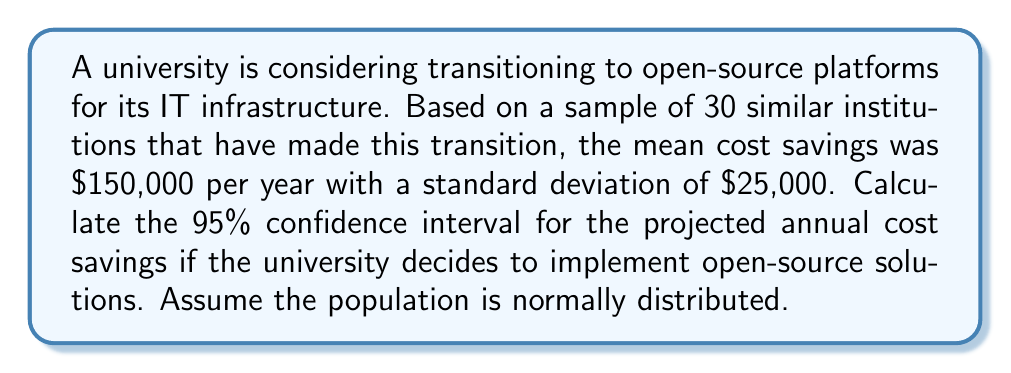Teach me how to tackle this problem. To calculate the 95% confidence interval, we'll follow these steps:

1. Identify the known values:
   - Sample size: $n = 30$
   - Sample mean: $\bar{x} = \$150,000$
   - Sample standard deviation: $s = \$25,000$
   - Confidence level: 95% (α = 0.05)

2. Find the critical value (t-score) for a 95% confidence interval with 29 degrees of freedom:
   $t_{0.025, 29} = 2.045$ (from t-distribution table)

3. Calculate the margin of error:
   $\text{Margin of Error} = t_{0.025, 29} \times \frac{s}{\sqrt{n}}$
   $= 2.045 \times \frac{\$25,000}{\sqrt{30}}$
   $= 2.045 \times \$4,564.35$
   $= \$9,334.10$

4. Calculate the confidence interval:
   $\text{CI} = \bar{x} \pm \text{Margin of Error}$
   $\text{Lower bound} = \$150,000 - \$9,334.10 = \$140,665.90$
   $\text{Upper bound} = \$150,000 + \$9,334.10 = \$159,334.10$

Therefore, the 95% confidence interval for the projected annual cost savings is (\$140,665.90, \$159,334.10).
Answer: (\$140,665.90, \$159,334.10) 